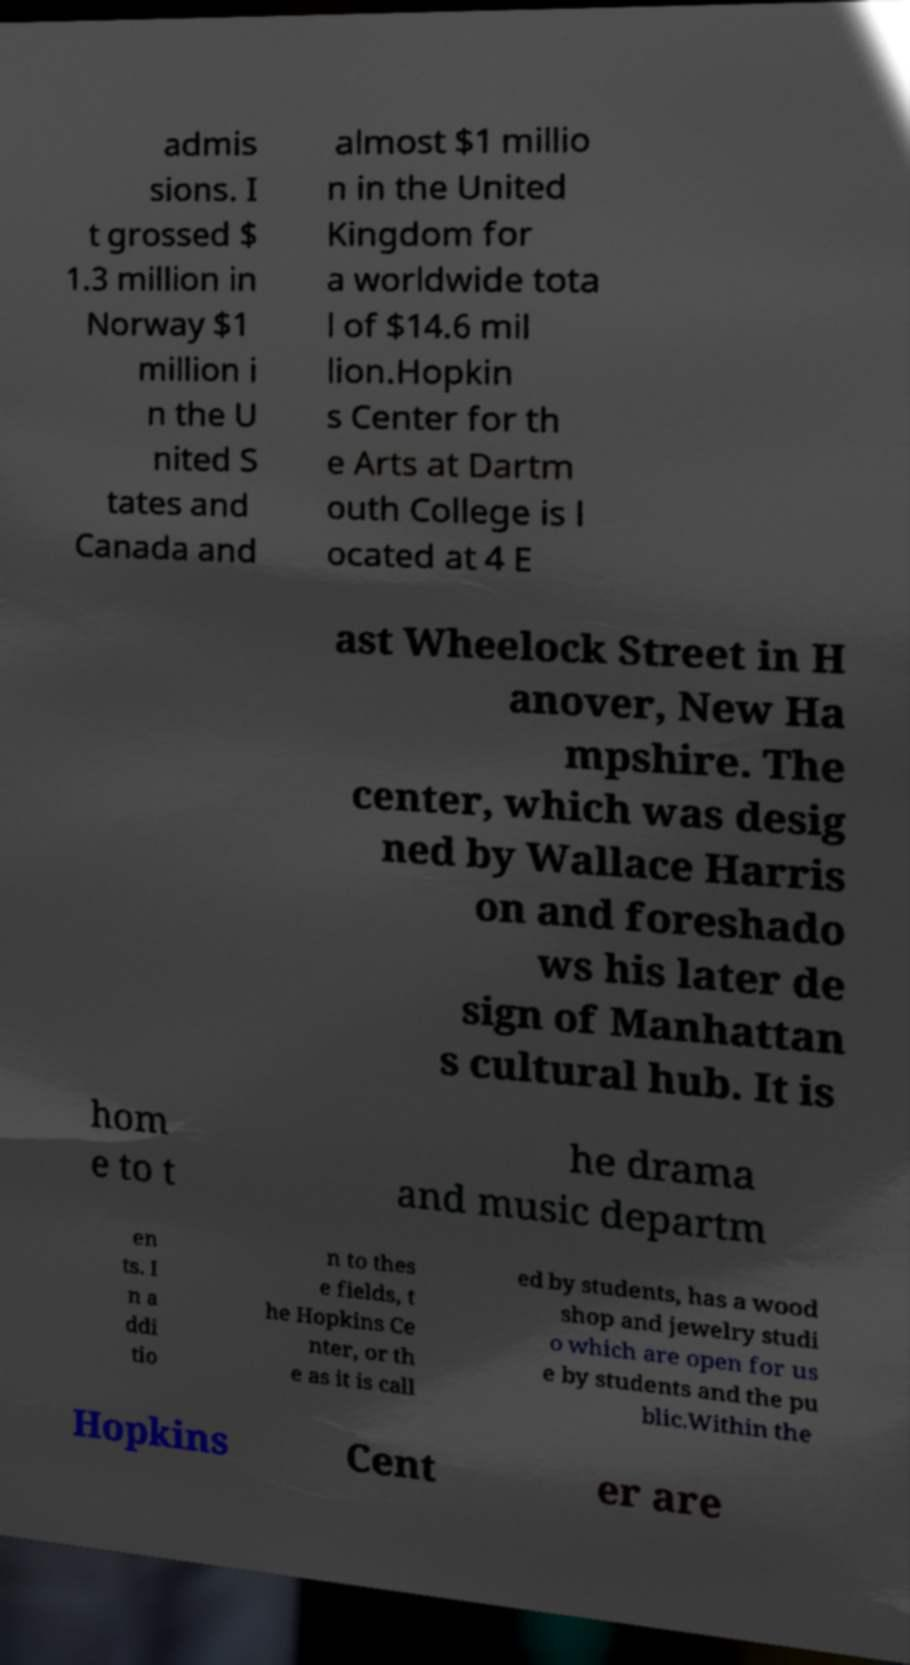For documentation purposes, I need the text within this image transcribed. Could you provide that? admis sions. I t grossed $ 1.3 million in Norway $1 million i n the U nited S tates and Canada and almost $1 millio n in the United Kingdom for a worldwide tota l of $14.6 mil lion.Hopkin s Center for th e Arts at Dartm outh College is l ocated at 4 E ast Wheelock Street in H anover, New Ha mpshire. The center, which was desig ned by Wallace Harris on and foreshado ws his later de sign of Manhattan s cultural hub. It is hom e to t he drama and music departm en ts. I n a ddi tio n to thes e fields, t he Hopkins Ce nter, or th e as it is call ed by students, has a wood shop and jewelry studi o which are open for us e by students and the pu blic.Within the Hopkins Cent er are 